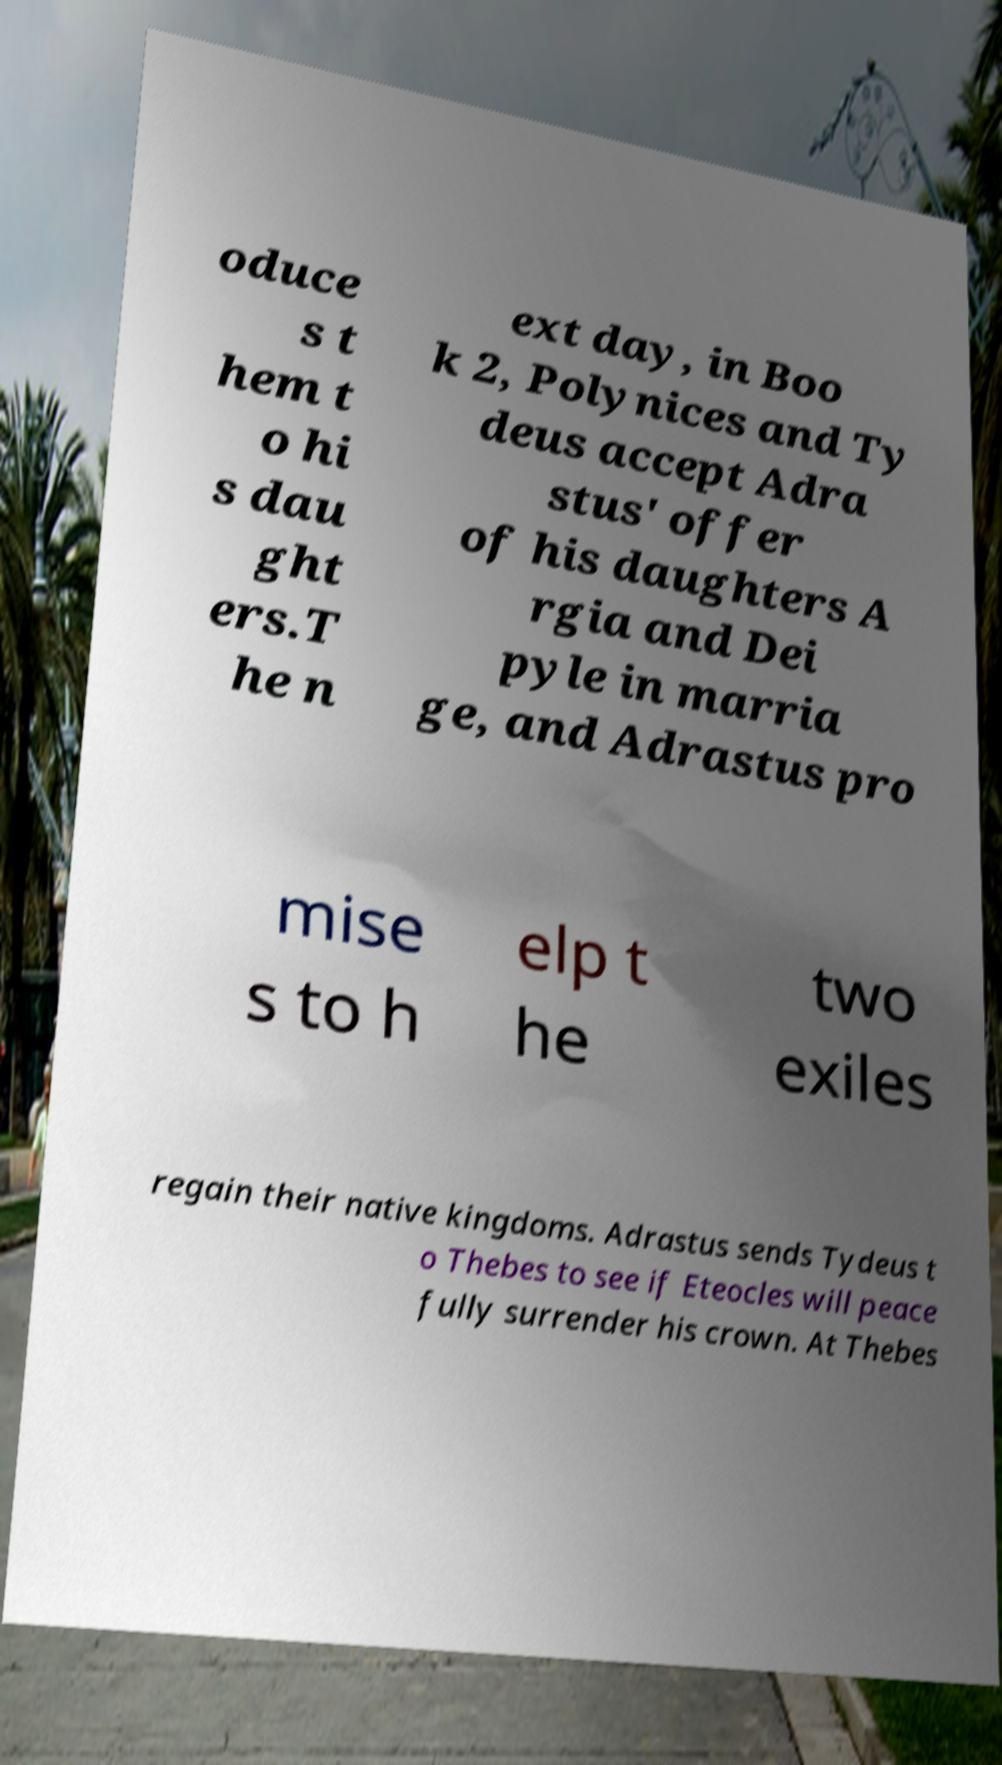Please read and relay the text visible in this image. What does it say? oduce s t hem t o hi s dau ght ers.T he n ext day, in Boo k 2, Polynices and Ty deus accept Adra stus' offer of his daughters A rgia and Dei pyle in marria ge, and Adrastus pro mise s to h elp t he two exiles regain their native kingdoms. Adrastus sends Tydeus t o Thebes to see if Eteocles will peace fully surrender his crown. At Thebes 